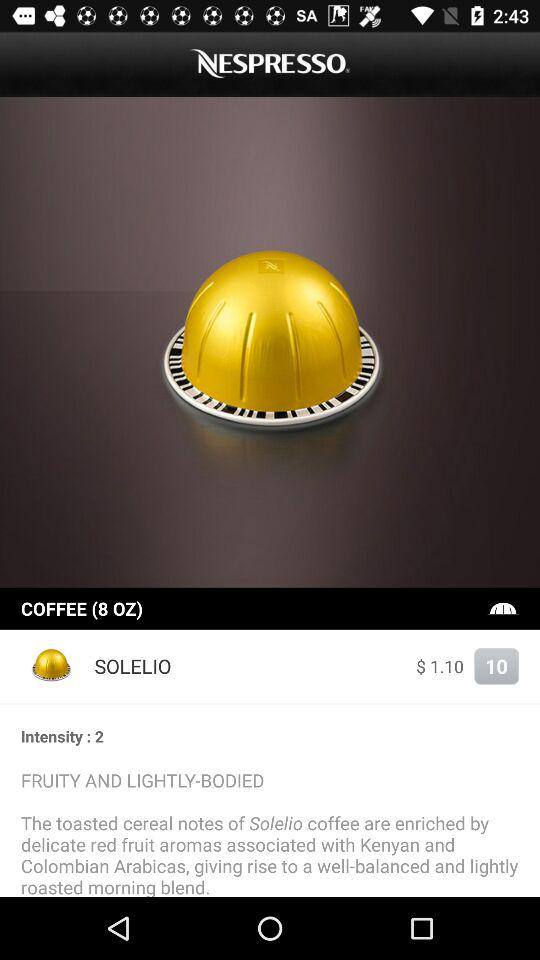What is the intensity? The intensity is 2. 